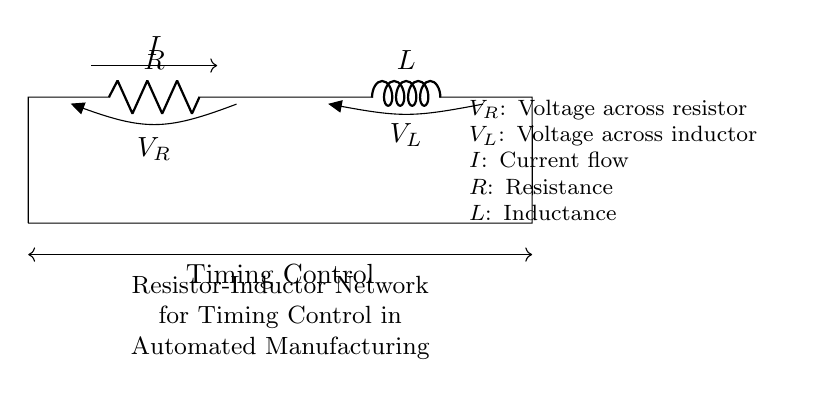What components are in the circuit? The circuit contains a resistor and an inductor, which are indicated by the symbols R and L, respectively.
Answer: resistor and inductor What is the voltage across the resistor? The voltage across the resistor is labeled as V_R on the circuit diagram, which is provided alongside the circuit.
Answer: V_R What role does the resistor play in this circuit? The resistor limits the current that passes through the circuit, which influences the timing control by affecting the rate of current change in conjunction with the inductor.
Answer: current limiting What is the total current flowing through the circuit? The total current flowing through the circuit is indicated as I, which flows from the resistor into the inductor.
Answer: I How does the inductor affect the circuit's timing behavior? The inductor stores energy in the form of a magnetic field when current passes through it, which affects the rate of change of the current, thereby influencing the timing in the manufacturing process.
Answer: energy storage What is the relationship between voltage and current in this resistor-inductor network? The relationship is defined by Kirchhoff's Voltage Law; the sum of the voltage across the resistor and the voltage across the inductor equals the total voltage in the circuit.
Answer: Kirchhoff's Voltage Law 